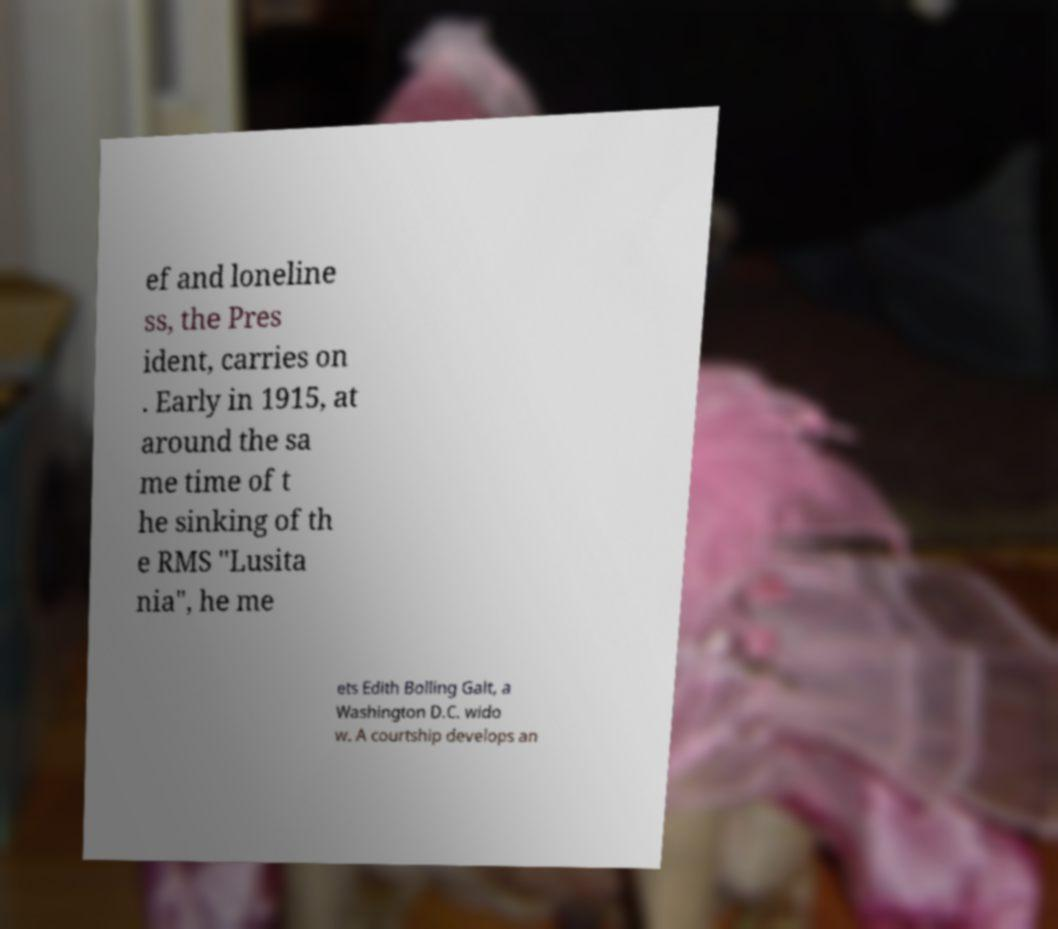Can you accurately transcribe the text from the provided image for me? ef and loneline ss, the Pres ident, carries on . Early in 1915, at around the sa me time of t he sinking of th e RMS "Lusita nia", he me ets Edith Bolling Galt, a Washington D.C. wido w. A courtship develops an 